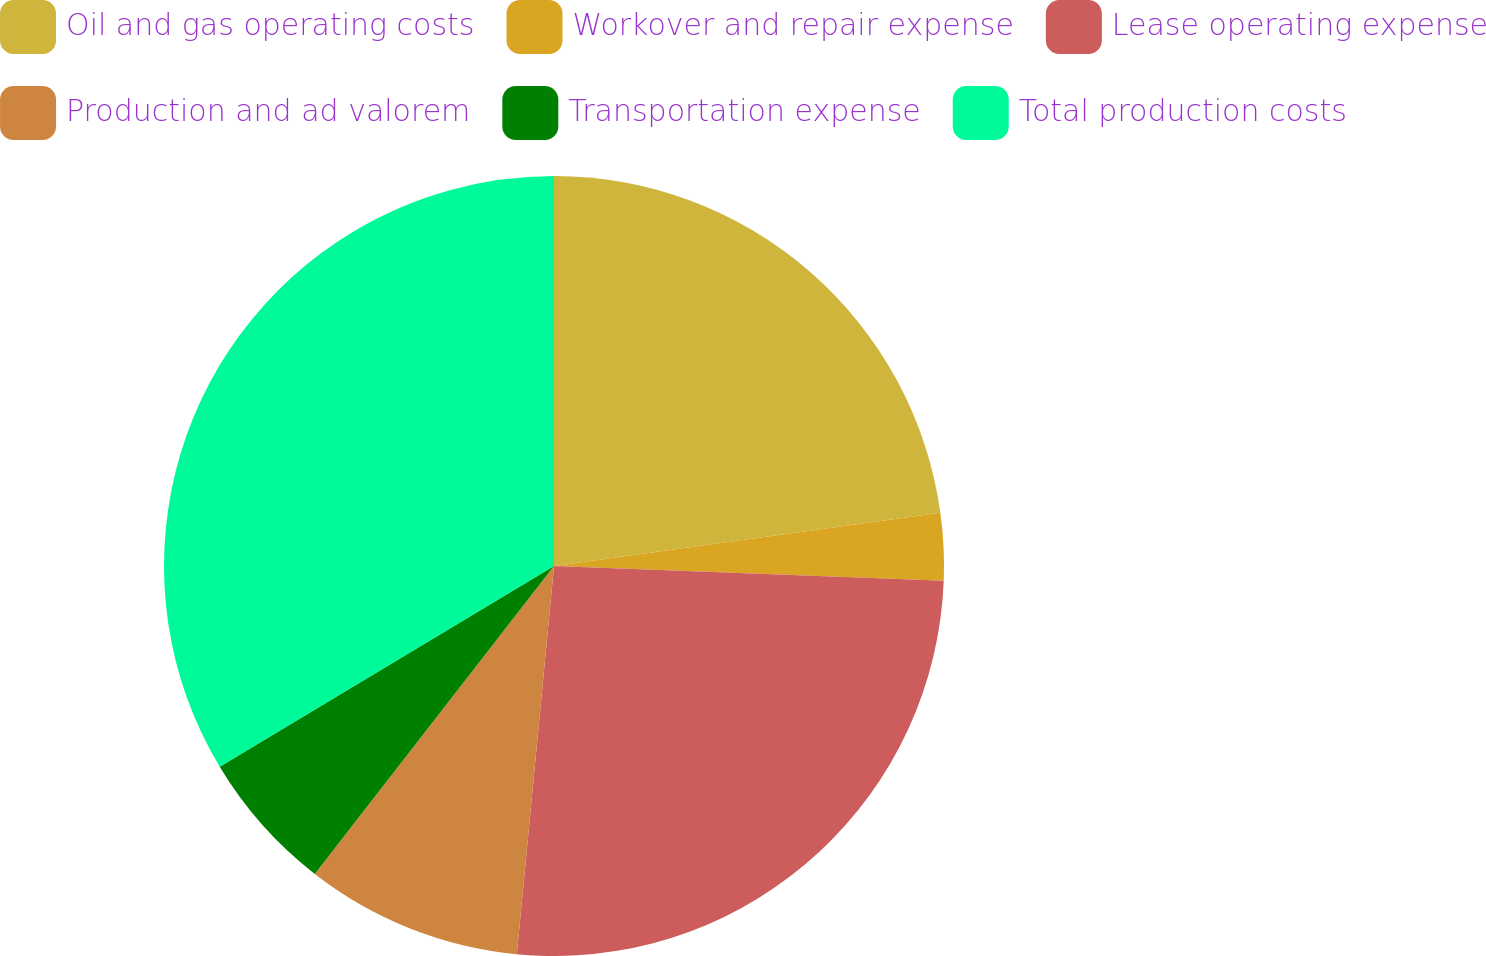Convert chart to OTSL. <chart><loc_0><loc_0><loc_500><loc_500><pie_chart><fcel>Oil and gas operating costs<fcel>Workover and repair expense<fcel>Lease operating expense<fcel>Production and ad valorem<fcel>Transportation expense<fcel>Total production costs<nl><fcel>22.82%<fcel>2.78%<fcel>25.92%<fcel>8.99%<fcel>5.88%<fcel>33.61%<nl></chart> 